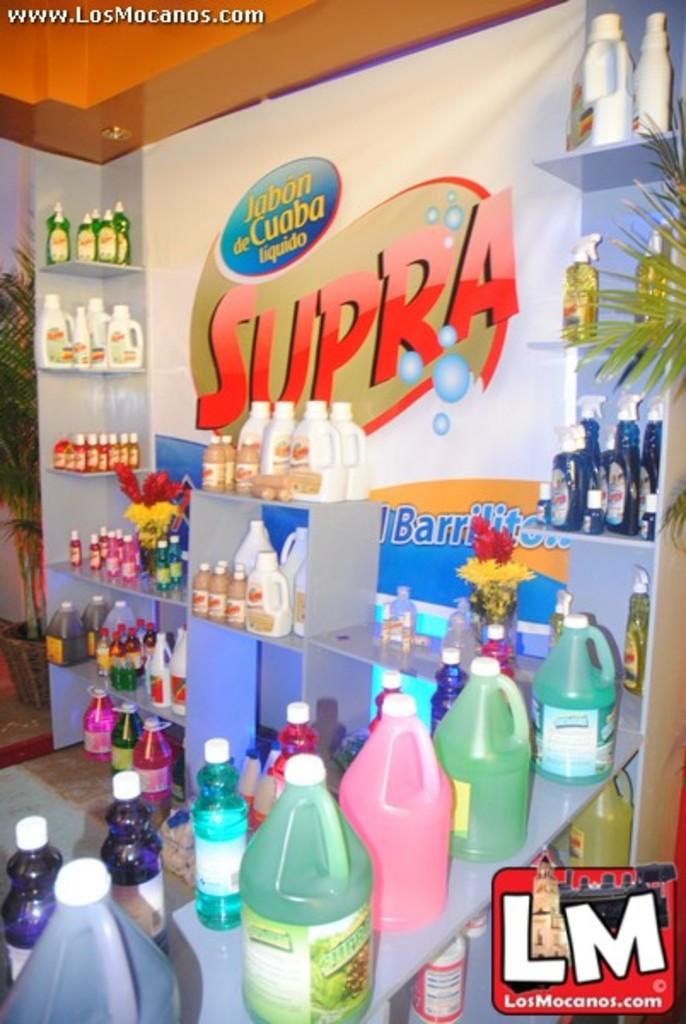<image>
Present a compact description of the photo's key features. A colorful display of Supra products depicts various colors and containers, is in full view. 